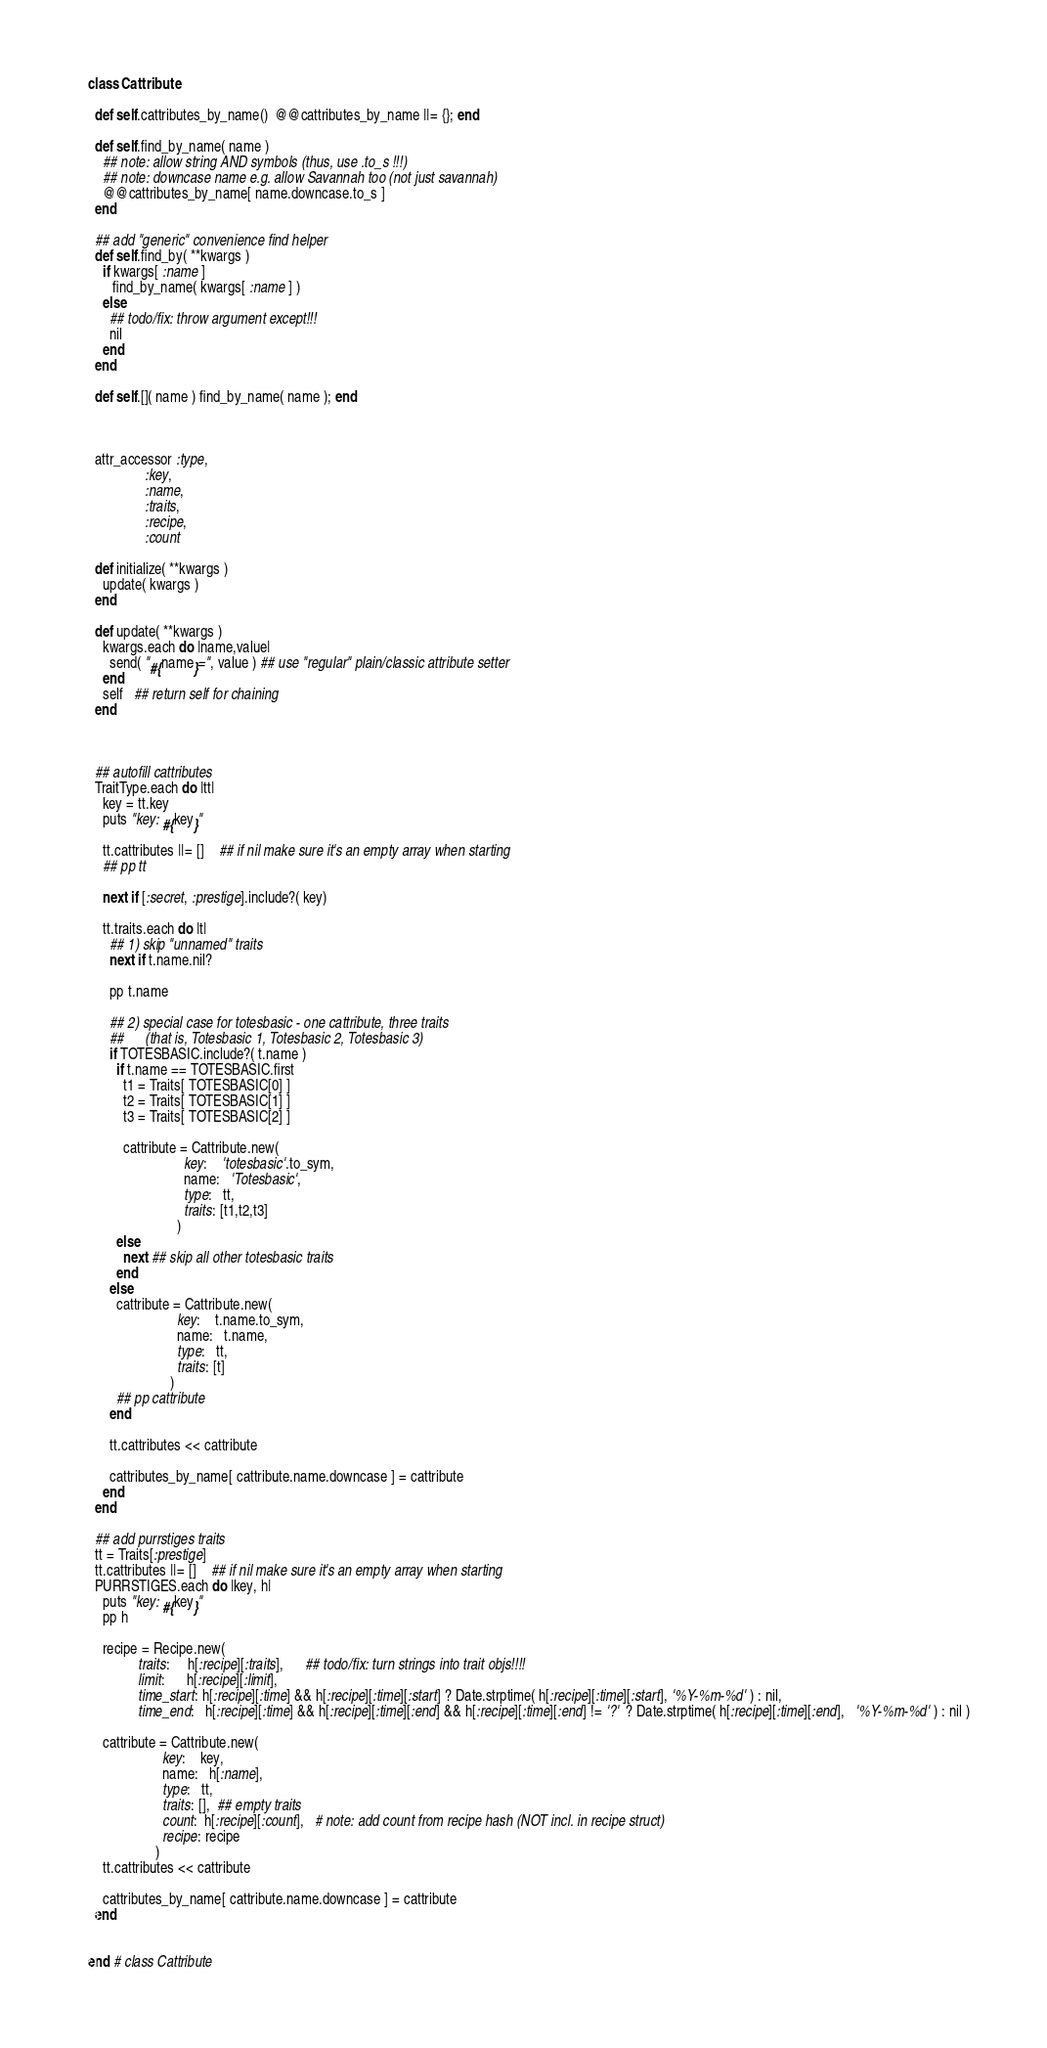<code> <loc_0><loc_0><loc_500><loc_500><_Ruby_>

class Cattribute

  def self.cattributes_by_name()  @@cattributes_by_name ||= {}; end

  def self.find_by_name( name )
    ## note: allow string AND symbols (thus, use .to_s !!!)
    ## note: downcase name e.g. allow Savannah too (not just savannah)
    @@cattributes_by_name[ name.downcase.to_s ]
  end

  ## add "generic" convenience find helper
  def self.find_by( **kwargs )
    if kwargs[ :name ]
       find_by_name( kwargs[ :name ] )
    else
      ## todo/fix: throw argument except!!!
      nil
    end
  end

  def self.[]( name ) find_by_name( name ); end



  attr_accessor :type,
                :key,
                :name,
                :traits,
                :recipe,
                :count

  def initialize( **kwargs )
    update( kwargs )
  end

  def update( **kwargs )
    kwargs.each do |name,value|
      send( "#{name}=", value ) ## use "regular" plain/classic attribute setter
    end
    self   ## return self for chaining
  end



  ## autofill cattributes
  TraitType.each do |tt|
    key = tt.key
    puts "key: #{key}"

    tt.cattributes ||= []    ## if nil make sure it's an empty array when starting
    ## pp tt

    next if [:secret, :prestige].include?( key)

    tt.traits.each do |t|
      ## 1) skip "unnamed" traits
      next if t.name.nil?

      pp t.name

      ## 2) special case for totesbasic - one cattribute, three traits
      ##      (that is, Totesbasic 1, Totesbasic 2, Totesbasic 3)
      if TOTESBASIC.include?( t.name )
        if t.name == TOTESBASIC.first
          t1 = Traits[ TOTESBASIC[0] ]
          t2 = Traits[ TOTESBASIC[1] ]
          t3 = Traits[ TOTESBASIC[2] ]

          cattribute = Cattribute.new(
                           key:    'totesbasic'.to_sym,
                           name:   'Totesbasic',
                           type:   tt,
                           traits: [t1,t2,t3]
                         )
        else
          next ## skip all other totesbasic traits
        end
      else
        cattribute = Cattribute.new(
                         key:    t.name.to_sym,
                         name:   t.name,
                         type:   tt,
                         traits: [t]
                       )
        ## pp cattribute
      end

      tt.cattributes << cattribute

      cattributes_by_name[ cattribute.name.downcase ] = cattribute
    end
  end

  ## add purrstiges traits
  tt = Traits[:prestige]
  tt.cattributes ||= []    ## if nil make sure it's an empty array when starting
  PURRSTIGES.each do |key, h|
    puts "key: #{key}"
    pp h

    recipe = Recipe.new(
              traits:     h[:recipe][:traits],      ## todo/fix: turn strings into trait objs!!!!
              limit:      h[:recipe][:limit],
              time_start: h[:recipe][:time] && h[:recipe][:time][:start] ? Date.strptime( h[:recipe][:time][:start], '%Y-%m-%d' ) : nil,
              time_end:   h[:recipe][:time] && h[:recipe][:time][:end] && h[:recipe][:time][:end] != '?'  ? Date.strptime( h[:recipe][:time][:end],   '%Y-%m-%d' ) : nil )

    cattribute = Cattribute.new(
                     key:    key,
                     name:   h[:name],
                     type:   tt,
                     traits: [],  ## empty traits
                     count:  h[:recipe][:count],   # note: add count from recipe hash (NOT incl. in recipe struct)
                     recipe: recipe
                   )
    tt.cattributes << cattribute

    cattributes_by_name[ cattribute.name.downcase ] = cattribute
  end


end # class Cattribute
</code> 